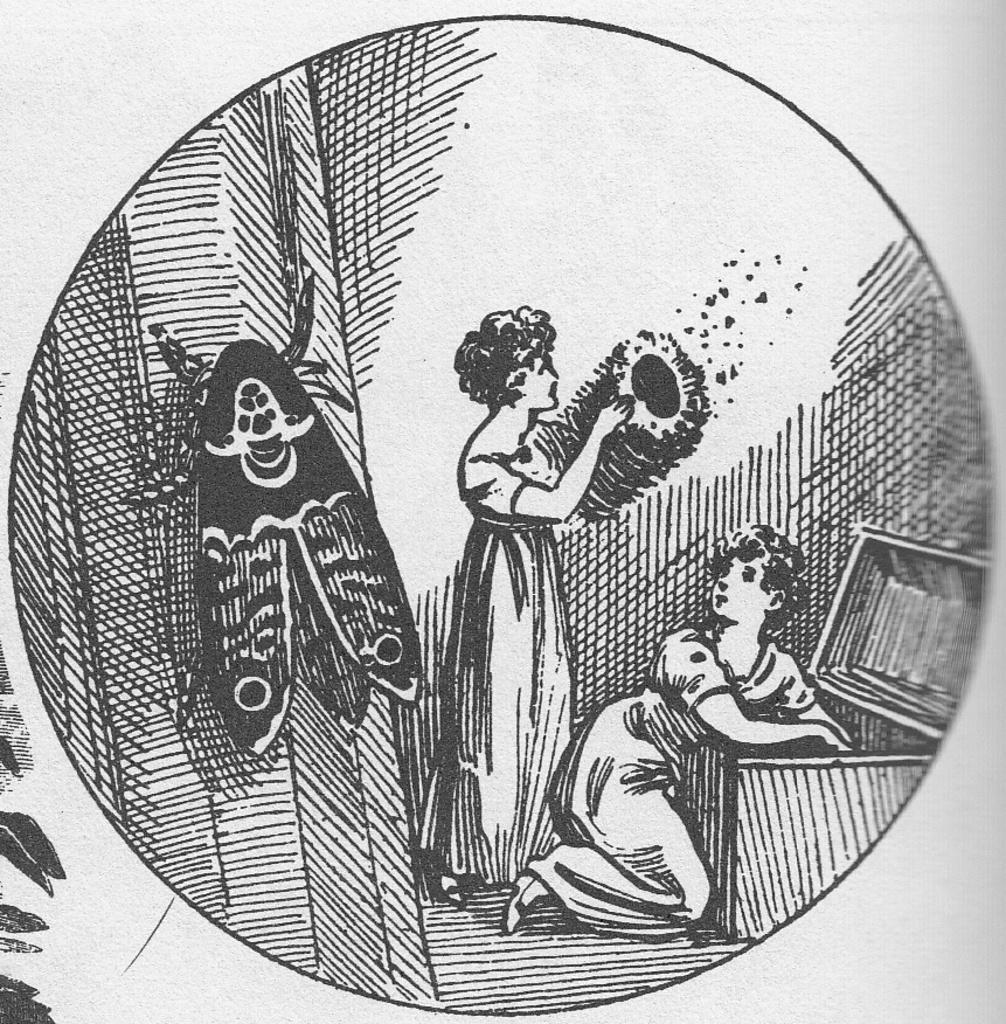Can you describe this image briefly? In the image there is print of two women standing with a huge box in front of them, on the left side there is a fly standing on the wall. 